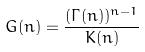Convert formula to latex. <formula><loc_0><loc_0><loc_500><loc_500>G ( n ) = \frac { ( \Gamma ( n ) ) ^ { n - 1 } } { K ( n ) }</formula> 